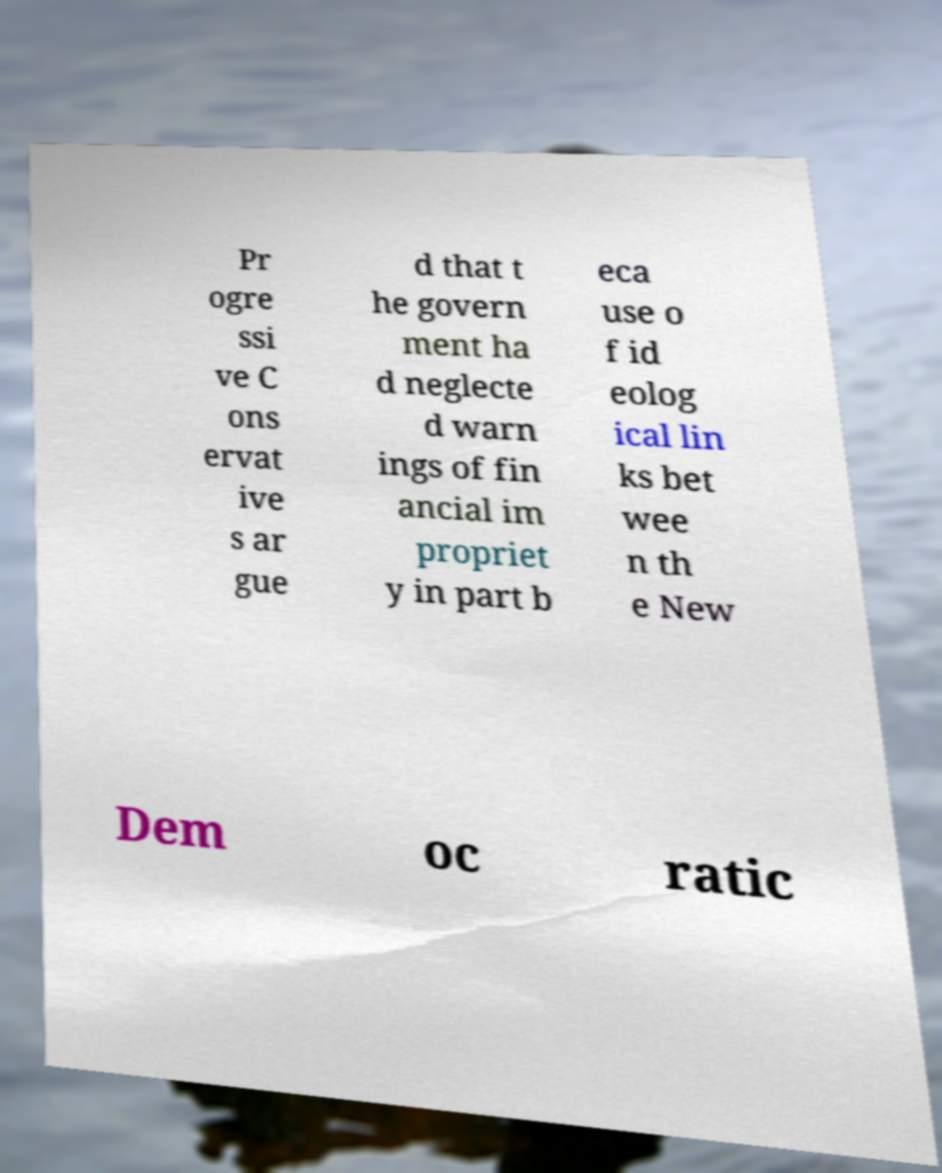Can you accurately transcribe the text from the provided image for me? Pr ogre ssi ve C ons ervat ive s ar gue d that t he govern ment ha d neglecte d warn ings of fin ancial im propriet y in part b eca use o f id eolog ical lin ks bet wee n th e New Dem oc ratic 